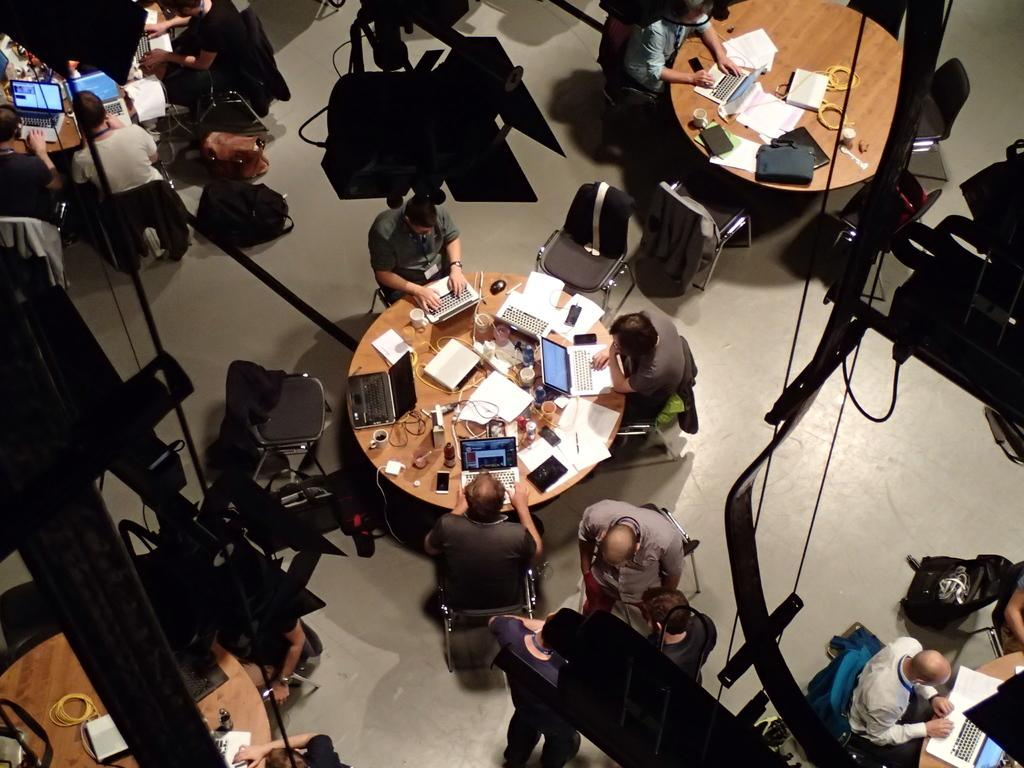What are the people in the image doing? The people in the image are sitting on chairs around the table. What objects can be seen on the table? There are laptops, papers, mobile phones, cups, and additional items on the table. Can you describe the additional items on the table? Unfortunately, the provided facts do not specify the nature of the additional items on the table. What might the people be using the laptops for? It is not possible to determine the specific purpose of the laptops from the image alone. What type of pipe can be seen in the image? There is no pipe present in the image. Can you describe the bedroom in the image? There is no bedroom present in the image; it features a table with people sitting around it. 